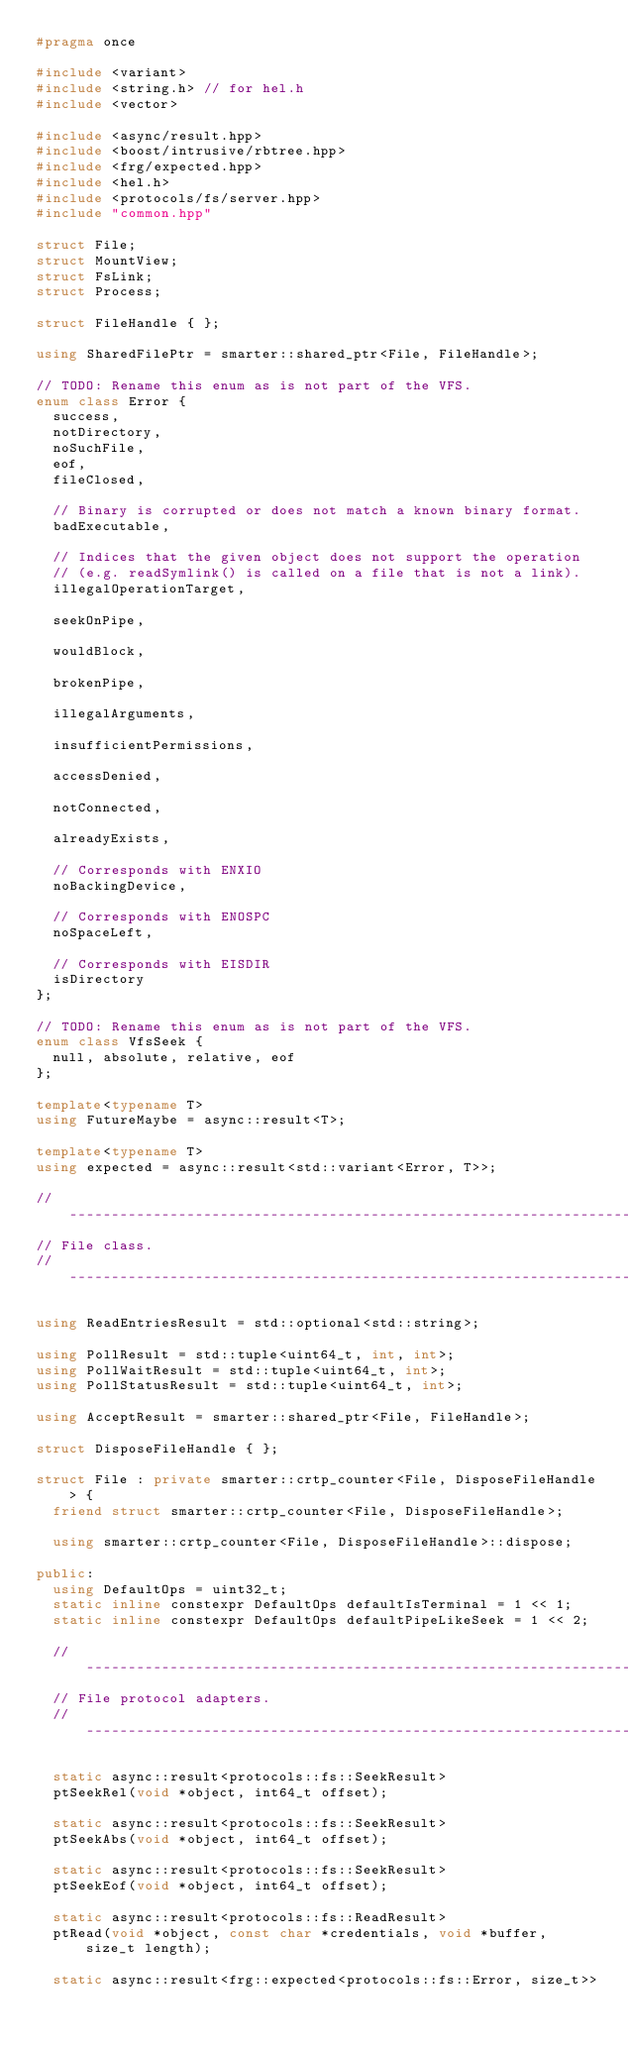Convert code to text. <code><loc_0><loc_0><loc_500><loc_500><_C++_>#pragma once

#include <variant>
#include <string.h> // for hel.h
#include <vector>

#include <async/result.hpp>
#include <boost/intrusive/rbtree.hpp>
#include <frg/expected.hpp>
#include <hel.h>
#include <protocols/fs/server.hpp>
#include "common.hpp"

struct File;
struct MountView;
struct FsLink;
struct Process;

struct FileHandle { };

using SharedFilePtr = smarter::shared_ptr<File, FileHandle>;

// TODO: Rename this enum as is not part of the VFS.
enum class Error {
	success,
	notDirectory,
	noSuchFile,
	eof,
	fileClosed,

	// Binary is corrupted or does not match a known binary format.
	badExecutable,

	// Indices that the given object does not support the operation
	// (e.g. readSymlink() is called on a file that is not a link).
	illegalOperationTarget,

	seekOnPipe,

	wouldBlock,

	brokenPipe,

	illegalArguments,

	insufficientPermissions,

	accessDenied,

	notConnected,

	alreadyExists,

	// Corresponds with ENXIO
	noBackingDevice,

	// Corresponds with ENOSPC
	noSpaceLeft,

	// Corresponds with EISDIR
	isDirectory
};

// TODO: Rename this enum as is not part of the VFS.
enum class VfsSeek {
	null, absolute, relative, eof
};

template<typename T>
using FutureMaybe = async::result<T>;

template<typename T>
using expected = async::result<std::variant<Error, T>>;

// ----------------------------------------------------------------------------
// File class.
// ----------------------------------------------------------------------------

using ReadEntriesResult = std::optional<std::string>;

using PollResult = std::tuple<uint64_t, int, int>;
using PollWaitResult = std::tuple<uint64_t, int>;
using PollStatusResult = std::tuple<uint64_t, int>;

using AcceptResult = smarter::shared_ptr<File, FileHandle>;

struct DisposeFileHandle { };

struct File : private smarter::crtp_counter<File, DisposeFileHandle> {
	friend struct smarter::crtp_counter<File, DisposeFileHandle>;

	using smarter::crtp_counter<File, DisposeFileHandle>::dispose;

public:
	using DefaultOps = uint32_t;
	static inline constexpr DefaultOps defaultIsTerminal = 1 << 1;
	static inline constexpr DefaultOps defaultPipeLikeSeek = 1 << 2;

	// ------------------------------------------------------------------------
	// File protocol adapters.
	// ------------------------------------------------------------------------

	static async::result<protocols::fs::SeekResult>
	ptSeekRel(void *object, int64_t offset);

	static async::result<protocols::fs::SeekResult>
	ptSeekAbs(void *object, int64_t offset);

	static async::result<protocols::fs::SeekResult>
	ptSeekEof(void *object, int64_t offset);

	static async::result<protocols::fs::ReadResult>
	ptRead(void *object, const char *credentials, void *buffer, size_t length);

	static async::result<frg::expected<protocols::fs::Error, size_t>></code> 